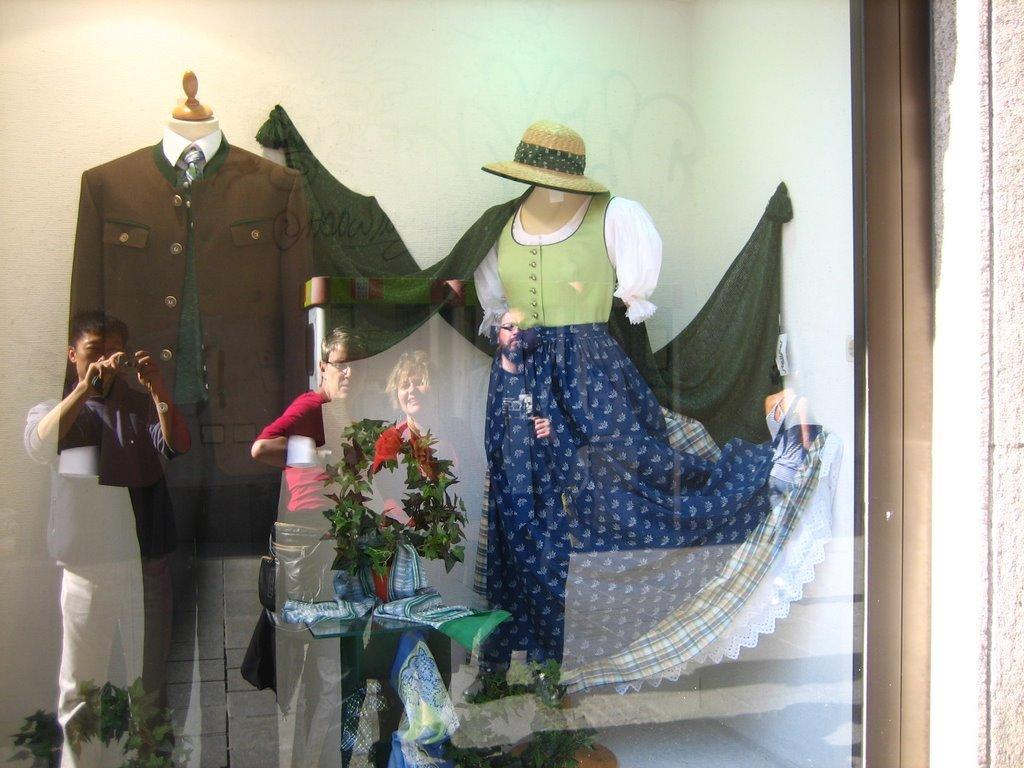What can be seen in the image due to the presence of reflective surfaces? There are people's reflections in the image. What objects are in front of the wall in the image? There are mannequins in front of the wall. What decorative element is present in the middle of the image? There is a floral wreath in the middle of the image. What type of window can be seen in the image? There is no window present in the image; it features people's reflections, mannequins, and a floral wreath. What room is the image taken in? The image does not provide enough information to determine the specific room in which it was taken. 